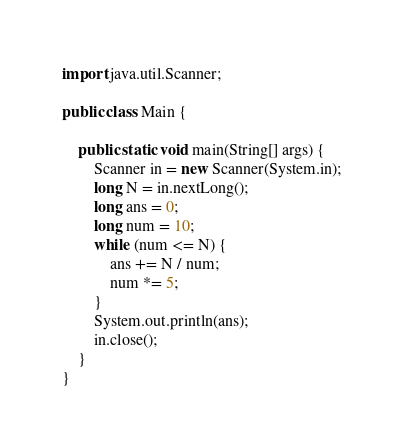<code> <loc_0><loc_0><loc_500><loc_500><_Java_>import java.util.Scanner;

public class Main {

	public static void main(String[] args) {
		Scanner in = new Scanner(System.in);
		long N = in.nextLong();
		long ans = 0;
		long num = 10;
		while (num <= N) {
			ans += N / num;
			num *= 5;
		}
		System.out.println(ans);
		in.close();
	}
}</code> 